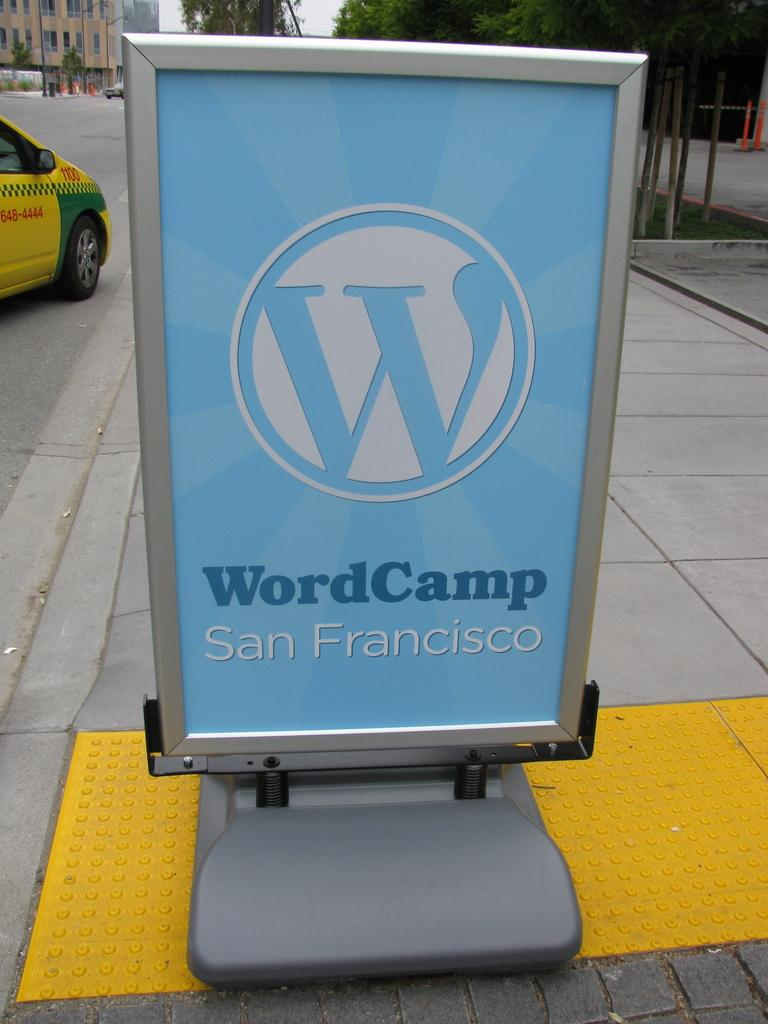<image>
Create a compact narrative representing the image presented. A blue sign for WordCamp in San Francisco 